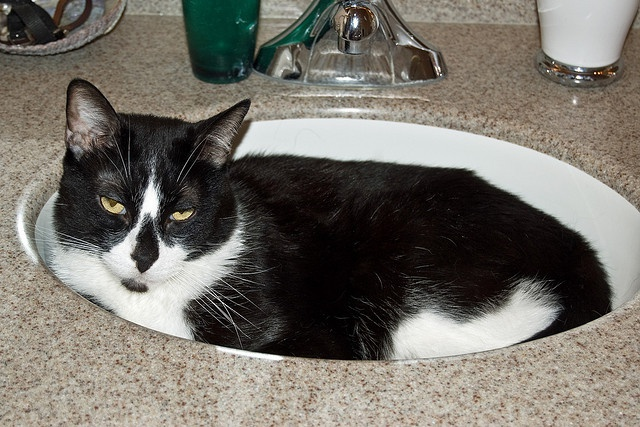Describe the objects in this image and their specific colors. I can see cat in black, lightgray, darkgray, and gray tones, sink in black, lightgray, darkgray, and gray tones, and cup in black, darkgreen, teal, and gray tones in this image. 